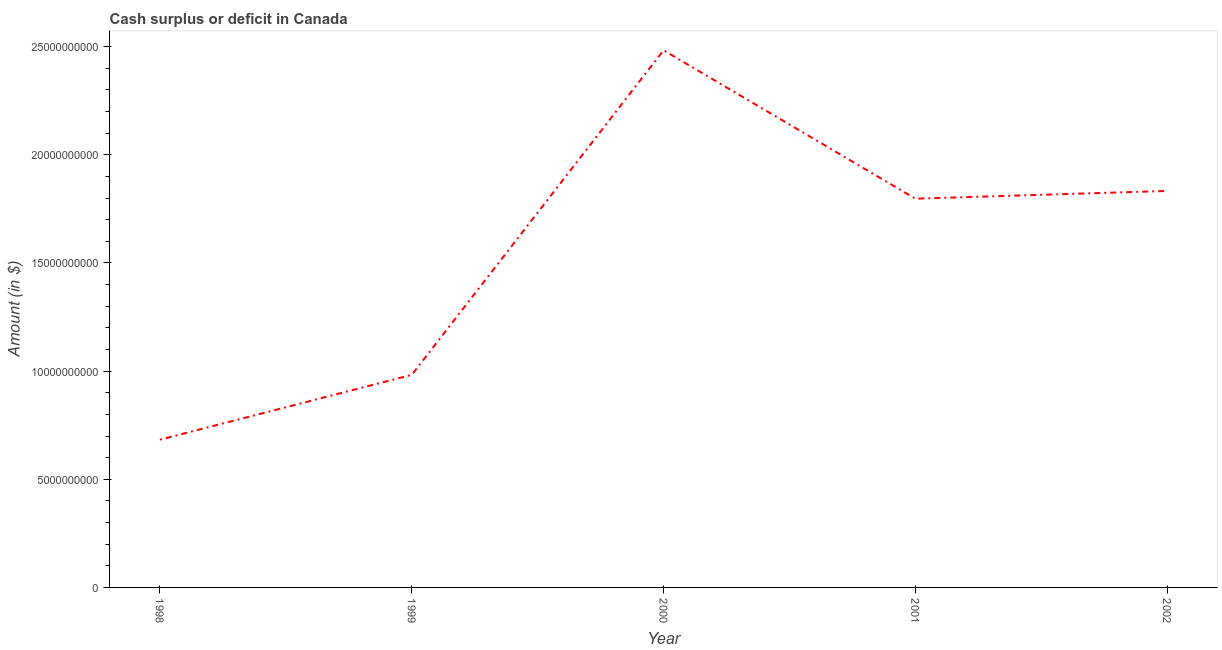What is the cash surplus or deficit in 1999?
Keep it short and to the point. 9.83e+09. Across all years, what is the maximum cash surplus or deficit?
Ensure brevity in your answer.  2.48e+1. Across all years, what is the minimum cash surplus or deficit?
Make the answer very short. 6.83e+09. What is the sum of the cash surplus or deficit?
Provide a succinct answer. 7.78e+1. What is the difference between the cash surplus or deficit in 1998 and 2001?
Your response must be concise. -1.11e+1. What is the average cash surplus or deficit per year?
Give a very brief answer. 1.56e+1. What is the median cash surplus or deficit?
Your answer should be very brief. 1.80e+1. What is the ratio of the cash surplus or deficit in 1999 to that in 2001?
Ensure brevity in your answer.  0.55. Is the cash surplus or deficit in 1998 less than that in 2001?
Provide a short and direct response. Yes. What is the difference between the highest and the second highest cash surplus or deficit?
Offer a very short reply. 6.50e+09. What is the difference between the highest and the lowest cash surplus or deficit?
Make the answer very short. 1.80e+1. Does the cash surplus or deficit monotonically increase over the years?
Ensure brevity in your answer.  No. How many years are there in the graph?
Your answer should be compact. 5. Are the values on the major ticks of Y-axis written in scientific E-notation?
Make the answer very short. No. What is the title of the graph?
Provide a succinct answer. Cash surplus or deficit in Canada. What is the label or title of the Y-axis?
Your answer should be compact. Amount (in $). What is the Amount (in $) in 1998?
Your answer should be very brief. 6.83e+09. What is the Amount (in $) of 1999?
Your response must be concise. 9.83e+09. What is the Amount (in $) of 2000?
Offer a terse response. 2.48e+1. What is the Amount (in $) in 2001?
Provide a short and direct response. 1.80e+1. What is the Amount (in $) of 2002?
Your answer should be very brief. 1.83e+1. What is the difference between the Amount (in $) in 1998 and 1999?
Your answer should be very brief. -3.00e+09. What is the difference between the Amount (in $) in 1998 and 2000?
Your answer should be compact. -1.80e+1. What is the difference between the Amount (in $) in 1998 and 2001?
Ensure brevity in your answer.  -1.11e+1. What is the difference between the Amount (in $) in 1998 and 2002?
Your response must be concise. -1.15e+1. What is the difference between the Amount (in $) in 1999 and 2000?
Provide a short and direct response. -1.50e+1. What is the difference between the Amount (in $) in 1999 and 2001?
Keep it short and to the point. -8.14e+09. What is the difference between the Amount (in $) in 1999 and 2002?
Make the answer very short. -8.50e+09. What is the difference between the Amount (in $) in 2000 and 2001?
Provide a succinct answer. 6.86e+09. What is the difference between the Amount (in $) in 2000 and 2002?
Ensure brevity in your answer.  6.50e+09. What is the difference between the Amount (in $) in 2001 and 2002?
Keep it short and to the point. -3.58e+08. What is the ratio of the Amount (in $) in 1998 to that in 1999?
Offer a terse response. 0.69. What is the ratio of the Amount (in $) in 1998 to that in 2000?
Make the answer very short. 0.28. What is the ratio of the Amount (in $) in 1998 to that in 2001?
Offer a very short reply. 0.38. What is the ratio of the Amount (in $) in 1998 to that in 2002?
Ensure brevity in your answer.  0.37. What is the ratio of the Amount (in $) in 1999 to that in 2000?
Offer a very short reply. 0.4. What is the ratio of the Amount (in $) in 1999 to that in 2001?
Offer a very short reply. 0.55. What is the ratio of the Amount (in $) in 1999 to that in 2002?
Keep it short and to the point. 0.54. What is the ratio of the Amount (in $) in 2000 to that in 2001?
Your response must be concise. 1.38. What is the ratio of the Amount (in $) in 2000 to that in 2002?
Provide a succinct answer. 1.35. 